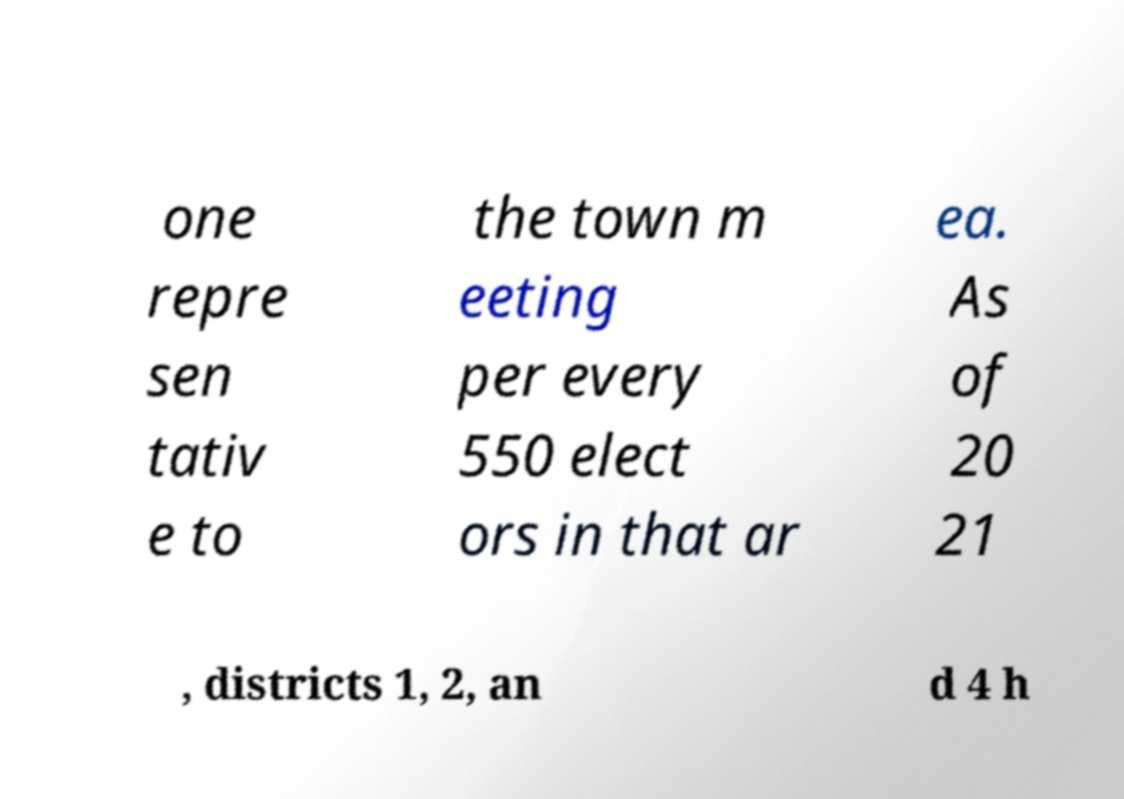Can you accurately transcribe the text from the provided image for me? one repre sen tativ e to the town m eeting per every 550 elect ors in that ar ea. As of 20 21 , districts 1, 2, an d 4 h 